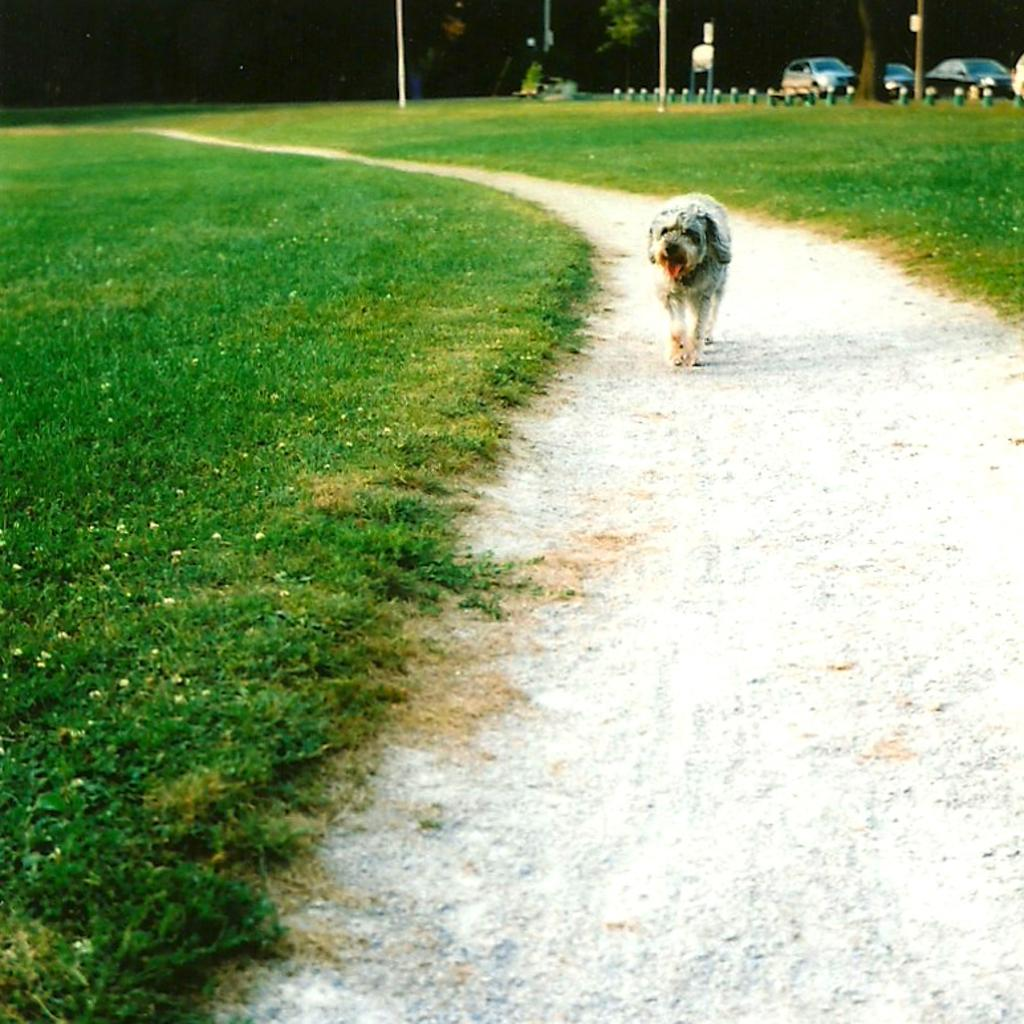What type of surface is on the ground in the image? There is grass on the ground in the image. What is the main subject in the center of the image? There is a dog in the center of the image. What can be seen in the distance in the image? There are cars visible in the background of the image. What type of vegetation is present in the background of the image? There is grass on the ground in the background of the image. What type of zipper can be seen on the dog's stomach in the image? There is no zipper present on the dog's stomach in the image. What position is the dog in the image? The dog's position cannot be determined from the image alone, as it only shows the dog from the front. 